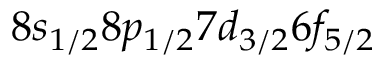Convert formula to latex. <formula><loc_0><loc_0><loc_500><loc_500>8 s _ { 1 / 2 } 8 p _ { 1 / 2 } 7 d _ { 3 / 2 } 6 f _ { 5 / 2 }</formula> 